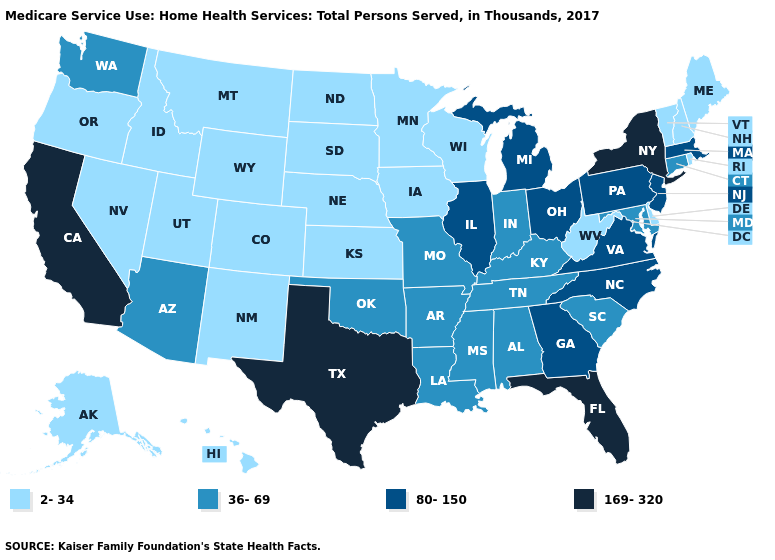What is the value of Kansas?
Keep it brief. 2-34. Does Alabama have a lower value than West Virginia?
Concise answer only. No. What is the value of Iowa?
Quick response, please. 2-34. Which states have the lowest value in the USA?
Write a very short answer. Alaska, Colorado, Delaware, Hawaii, Idaho, Iowa, Kansas, Maine, Minnesota, Montana, Nebraska, Nevada, New Hampshire, New Mexico, North Dakota, Oregon, Rhode Island, South Dakota, Utah, Vermont, West Virginia, Wisconsin, Wyoming. Name the states that have a value in the range 80-150?
Be succinct. Georgia, Illinois, Massachusetts, Michigan, New Jersey, North Carolina, Ohio, Pennsylvania, Virginia. What is the value of Hawaii?
Write a very short answer. 2-34. What is the lowest value in the Northeast?
Answer briefly. 2-34. Does Oklahoma have the lowest value in the USA?
Quick response, please. No. Name the states that have a value in the range 169-320?
Keep it brief. California, Florida, New York, Texas. Does Idaho have the same value as North Dakota?
Short answer required. Yes. What is the value of Missouri?
Quick response, please. 36-69. Does Wisconsin have the highest value in the MidWest?
Be succinct. No. Does New Jersey have the highest value in the Northeast?
Write a very short answer. No. Which states hav the highest value in the South?
Be succinct. Florida, Texas. 